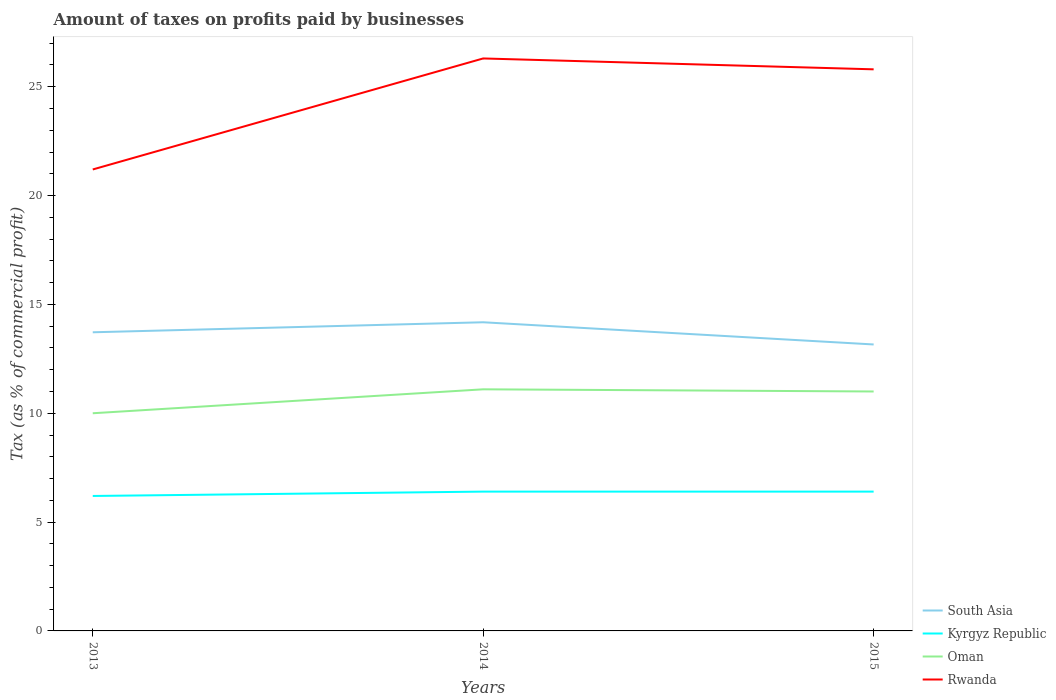How many different coloured lines are there?
Your response must be concise. 4. Does the line corresponding to Rwanda intersect with the line corresponding to Oman?
Your response must be concise. No. Is the number of lines equal to the number of legend labels?
Give a very brief answer. Yes. Across all years, what is the maximum percentage of taxes paid by businesses in Rwanda?
Offer a terse response. 21.2. What is the total percentage of taxes paid by businesses in Oman in the graph?
Make the answer very short. -1. What is the difference between the highest and the second highest percentage of taxes paid by businesses in Oman?
Ensure brevity in your answer.  1.1. Is the percentage of taxes paid by businesses in Kyrgyz Republic strictly greater than the percentage of taxes paid by businesses in Oman over the years?
Keep it short and to the point. Yes. How many lines are there?
Give a very brief answer. 4. What is the difference between two consecutive major ticks on the Y-axis?
Your answer should be compact. 5. Does the graph contain grids?
Make the answer very short. No. What is the title of the graph?
Offer a terse response. Amount of taxes on profits paid by businesses. Does "Greece" appear as one of the legend labels in the graph?
Keep it short and to the point. No. What is the label or title of the X-axis?
Your answer should be compact. Years. What is the label or title of the Y-axis?
Your answer should be compact. Tax (as % of commercial profit). What is the Tax (as % of commercial profit) of South Asia in 2013?
Keep it short and to the point. 13.72. What is the Tax (as % of commercial profit) in Kyrgyz Republic in 2013?
Keep it short and to the point. 6.2. What is the Tax (as % of commercial profit) in Rwanda in 2013?
Your answer should be compact. 21.2. What is the Tax (as % of commercial profit) in South Asia in 2014?
Provide a succinct answer. 14.18. What is the Tax (as % of commercial profit) in Kyrgyz Republic in 2014?
Your response must be concise. 6.4. What is the Tax (as % of commercial profit) of Oman in 2014?
Keep it short and to the point. 11.1. What is the Tax (as % of commercial profit) in Rwanda in 2014?
Make the answer very short. 26.3. What is the Tax (as % of commercial profit) of South Asia in 2015?
Your answer should be compact. 13.16. What is the Tax (as % of commercial profit) of Kyrgyz Republic in 2015?
Provide a short and direct response. 6.4. What is the Tax (as % of commercial profit) in Rwanda in 2015?
Give a very brief answer. 25.8. Across all years, what is the maximum Tax (as % of commercial profit) of South Asia?
Keep it short and to the point. 14.18. Across all years, what is the maximum Tax (as % of commercial profit) of Rwanda?
Keep it short and to the point. 26.3. Across all years, what is the minimum Tax (as % of commercial profit) of South Asia?
Your answer should be compact. 13.16. Across all years, what is the minimum Tax (as % of commercial profit) in Oman?
Your answer should be compact. 10. Across all years, what is the minimum Tax (as % of commercial profit) in Rwanda?
Offer a terse response. 21.2. What is the total Tax (as % of commercial profit) of South Asia in the graph?
Make the answer very short. 41.06. What is the total Tax (as % of commercial profit) of Kyrgyz Republic in the graph?
Your answer should be very brief. 19. What is the total Tax (as % of commercial profit) in Oman in the graph?
Offer a very short reply. 32.1. What is the total Tax (as % of commercial profit) of Rwanda in the graph?
Give a very brief answer. 73.3. What is the difference between the Tax (as % of commercial profit) of South Asia in 2013 and that in 2014?
Provide a succinct answer. -0.46. What is the difference between the Tax (as % of commercial profit) of Kyrgyz Republic in 2013 and that in 2014?
Provide a succinct answer. -0.2. What is the difference between the Tax (as % of commercial profit) in Oman in 2013 and that in 2014?
Your answer should be very brief. -1.1. What is the difference between the Tax (as % of commercial profit) of Rwanda in 2013 and that in 2014?
Offer a terse response. -5.1. What is the difference between the Tax (as % of commercial profit) of South Asia in 2013 and that in 2015?
Provide a succinct answer. 0.56. What is the difference between the Tax (as % of commercial profit) in Kyrgyz Republic in 2013 and that in 2015?
Make the answer very short. -0.2. What is the difference between the Tax (as % of commercial profit) of Oman in 2013 and that in 2015?
Ensure brevity in your answer.  -1. What is the difference between the Tax (as % of commercial profit) in Rwanda in 2013 and that in 2015?
Provide a succinct answer. -4.6. What is the difference between the Tax (as % of commercial profit) in South Asia in 2014 and that in 2015?
Your answer should be compact. 1.02. What is the difference between the Tax (as % of commercial profit) in Rwanda in 2014 and that in 2015?
Provide a succinct answer. 0.5. What is the difference between the Tax (as % of commercial profit) in South Asia in 2013 and the Tax (as % of commercial profit) in Kyrgyz Republic in 2014?
Provide a succinct answer. 7.32. What is the difference between the Tax (as % of commercial profit) of South Asia in 2013 and the Tax (as % of commercial profit) of Oman in 2014?
Provide a short and direct response. 2.62. What is the difference between the Tax (as % of commercial profit) of South Asia in 2013 and the Tax (as % of commercial profit) of Rwanda in 2014?
Make the answer very short. -12.58. What is the difference between the Tax (as % of commercial profit) of Kyrgyz Republic in 2013 and the Tax (as % of commercial profit) of Oman in 2014?
Offer a terse response. -4.9. What is the difference between the Tax (as % of commercial profit) in Kyrgyz Republic in 2013 and the Tax (as % of commercial profit) in Rwanda in 2014?
Keep it short and to the point. -20.1. What is the difference between the Tax (as % of commercial profit) in Oman in 2013 and the Tax (as % of commercial profit) in Rwanda in 2014?
Provide a succinct answer. -16.3. What is the difference between the Tax (as % of commercial profit) of South Asia in 2013 and the Tax (as % of commercial profit) of Kyrgyz Republic in 2015?
Provide a succinct answer. 7.32. What is the difference between the Tax (as % of commercial profit) of South Asia in 2013 and the Tax (as % of commercial profit) of Oman in 2015?
Keep it short and to the point. 2.72. What is the difference between the Tax (as % of commercial profit) of South Asia in 2013 and the Tax (as % of commercial profit) of Rwanda in 2015?
Keep it short and to the point. -12.08. What is the difference between the Tax (as % of commercial profit) of Kyrgyz Republic in 2013 and the Tax (as % of commercial profit) of Oman in 2015?
Give a very brief answer. -4.8. What is the difference between the Tax (as % of commercial profit) in Kyrgyz Republic in 2013 and the Tax (as % of commercial profit) in Rwanda in 2015?
Provide a succinct answer. -19.6. What is the difference between the Tax (as % of commercial profit) in Oman in 2013 and the Tax (as % of commercial profit) in Rwanda in 2015?
Your response must be concise. -15.8. What is the difference between the Tax (as % of commercial profit) of South Asia in 2014 and the Tax (as % of commercial profit) of Kyrgyz Republic in 2015?
Give a very brief answer. 7.78. What is the difference between the Tax (as % of commercial profit) of South Asia in 2014 and the Tax (as % of commercial profit) of Oman in 2015?
Provide a short and direct response. 3.18. What is the difference between the Tax (as % of commercial profit) of South Asia in 2014 and the Tax (as % of commercial profit) of Rwanda in 2015?
Your answer should be very brief. -11.62. What is the difference between the Tax (as % of commercial profit) in Kyrgyz Republic in 2014 and the Tax (as % of commercial profit) in Rwanda in 2015?
Your answer should be very brief. -19.4. What is the difference between the Tax (as % of commercial profit) in Oman in 2014 and the Tax (as % of commercial profit) in Rwanda in 2015?
Provide a succinct answer. -14.7. What is the average Tax (as % of commercial profit) of South Asia per year?
Provide a short and direct response. 13.69. What is the average Tax (as % of commercial profit) in Kyrgyz Republic per year?
Give a very brief answer. 6.33. What is the average Tax (as % of commercial profit) of Rwanda per year?
Your response must be concise. 24.43. In the year 2013, what is the difference between the Tax (as % of commercial profit) of South Asia and Tax (as % of commercial profit) of Kyrgyz Republic?
Make the answer very short. 7.52. In the year 2013, what is the difference between the Tax (as % of commercial profit) in South Asia and Tax (as % of commercial profit) in Oman?
Your answer should be compact. 3.72. In the year 2013, what is the difference between the Tax (as % of commercial profit) of South Asia and Tax (as % of commercial profit) of Rwanda?
Provide a succinct answer. -7.48. In the year 2014, what is the difference between the Tax (as % of commercial profit) in South Asia and Tax (as % of commercial profit) in Kyrgyz Republic?
Ensure brevity in your answer.  7.78. In the year 2014, what is the difference between the Tax (as % of commercial profit) in South Asia and Tax (as % of commercial profit) in Oman?
Offer a very short reply. 3.08. In the year 2014, what is the difference between the Tax (as % of commercial profit) in South Asia and Tax (as % of commercial profit) in Rwanda?
Ensure brevity in your answer.  -12.12. In the year 2014, what is the difference between the Tax (as % of commercial profit) of Kyrgyz Republic and Tax (as % of commercial profit) of Oman?
Keep it short and to the point. -4.7. In the year 2014, what is the difference between the Tax (as % of commercial profit) in Kyrgyz Republic and Tax (as % of commercial profit) in Rwanda?
Offer a very short reply. -19.9. In the year 2014, what is the difference between the Tax (as % of commercial profit) of Oman and Tax (as % of commercial profit) of Rwanda?
Give a very brief answer. -15.2. In the year 2015, what is the difference between the Tax (as % of commercial profit) in South Asia and Tax (as % of commercial profit) in Kyrgyz Republic?
Keep it short and to the point. 6.76. In the year 2015, what is the difference between the Tax (as % of commercial profit) in South Asia and Tax (as % of commercial profit) in Oman?
Provide a short and direct response. 2.16. In the year 2015, what is the difference between the Tax (as % of commercial profit) in South Asia and Tax (as % of commercial profit) in Rwanda?
Keep it short and to the point. -12.64. In the year 2015, what is the difference between the Tax (as % of commercial profit) in Kyrgyz Republic and Tax (as % of commercial profit) in Rwanda?
Offer a very short reply. -19.4. In the year 2015, what is the difference between the Tax (as % of commercial profit) of Oman and Tax (as % of commercial profit) of Rwanda?
Give a very brief answer. -14.8. What is the ratio of the Tax (as % of commercial profit) in South Asia in 2013 to that in 2014?
Offer a terse response. 0.97. What is the ratio of the Tax (as % of commercial profit) in Kyrgyz Republic in 2013 to that in 2014?
Your answer should be very brief. 0.97. What is the ratio of the Tax (as % of commercial profit) in Oman in 2013 to that in 2014?
Provide a succinct answer. 0.9. What is the ratio of the Tax (as % of commercial profit) of Rwanda in 2013 to that in 2014?
Provide a short and direct response. 0.81. What is the ratio of the Tax (as % of commercial profit) of South Asia in 2013 to that in 2015?
Keep it short and to the point. 1.04. What is the ratio of the Tax (as % of commercial profit) in Kyrgyz Republic in 2013 to that in 2015?
Offer a very short reply. 0.97. What is the ratio of the Tax (as % of commercial profit) in Oman in 2013 to that in 2015?
Make the answer very short. 0.91. What is the ratio of the Tax (as % of commercial profit) of Rwanda in 2013 to that in 2015?
Provide a succinct answer. 0.82. What is the ratio of the Tax (as % of commercial profit) in South Asia in 2014 to that in 2015?
Provide a succinct answer. 1.08. What is the ratio of the Tax (as % of commercial profit) in Kyrgyz Republic in 2014 to that in 2015?
Offer a very short reply. 1. What is the ratio of the Tax (as % of commercial profit) of Oman in 2014 to that in 2015?
Keep it short and to the point. 1.01. What is the ratio of the Tax (as % of commercial profit) of Rwanda in 2014 to that in 2015?
Offer a terse response. 1.02. What is the difference between the highest and the second highest Tax (as % of commercial profit) of South Asia?
Your response must be concise. 0.46. What is the difference between the highest and the second highest Tax (as % of commercial profit) of Kyrgyz Republic?
Keep it short and to the point. 0. What is the difference between the highest and the second highest Tax (as % of commercial profit) of Rwanda?
Your response must be concise. 0.5. What is the difference between the highest and the lowest Tax (as % of commercial profit) in South Asia?
Give a very brief answer. 1.02. What is the difference between the highest and the lowest Tax (as % of commercial profit) of Kyrgyz Republic?
Keep it short and to the point. 0.2. What is the difference between the highest and the lowest Tax (as % of commercial profit) of Oman?
Ensure brevity in your answer.  1.1. 